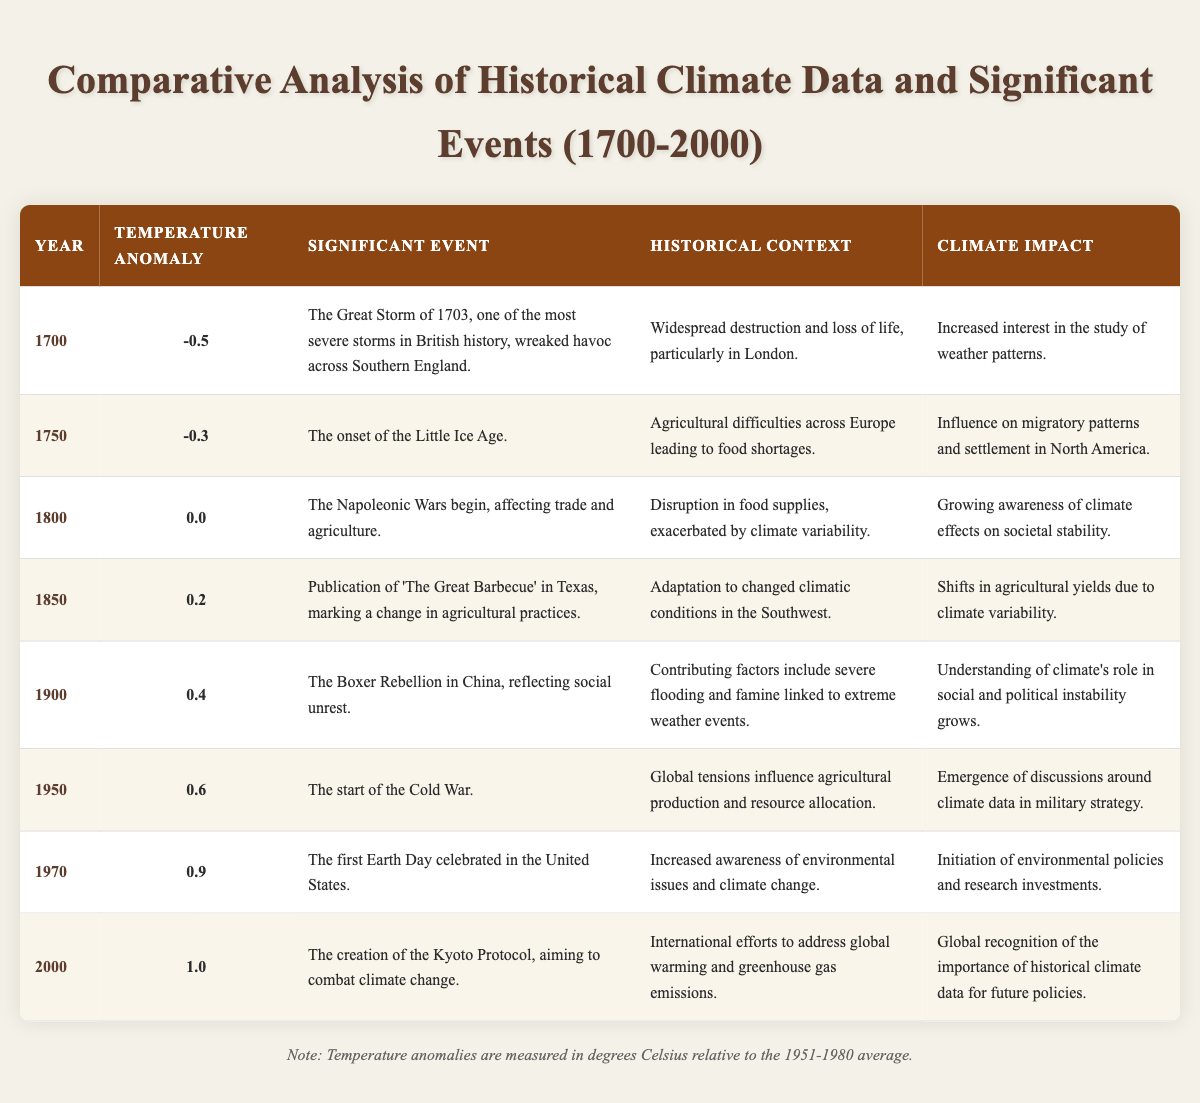What was the temperature anomaly in 1900? The table shows that the temperature anomaly for the year 1900 is 0.4 degrees Celsius.
Answer: 0.4 What significant event occurred in 1950? According to the table, the significant event in 1950 was the start of the Cold War.
Answer: Start of the Cold War Which year had the highest temperature anomaly? Analyzing the temperature anomalies listed, the highest value is 1.0 in the year 2000.
Answer: 2000 Was there a significant event linked to severe weather in 1800? The table indicates that the Napoleonic Wars, which began in 1800, were affected by disruptions in food supplies due to climate variability. Therefore, yes, this connects to severe weather.
Answer: Yes What was the temperature anomaly in the year of the Great Storm of 1703? The table notes that the year 1700, leading to the Great Storm of 1703, had a temperature anomaly of -0.5 degrees Celsius.
Answer: -0.5 What is the climate impact associated with the creation of the Kyoto Protocol in 2000? The impact listed for the year 2000 states the global recognition of the importance of historical climate data for future policies.
Answer: Global recognition of historical climate data importance Calculate the average temperature anomaly from 1700 to 2000. To find the average, add all temperature anomalies: (-0.5) + (-0.3) + 0.0 + 0.2 + 0.4 + 0.6 + 0.9 + 1.0 = 2.3. There are 8 data points, so 2.3 / 8 = 0.2875, approximately 0.29 degrees Celsius.
Answer: 0.29 In which year did the first Earth Day occur and what was the temperature anomaly that year? The table shows that the first Earth Day was celebrated in 1970 with a temperature anomaly of 0.9 degrees Celsius.
Answer: 1970, 0.9 Was there a historical context of famine linked to extreme weather during the Boxer Rebellion? The table confirms that the Boxer Rebellion in 1900 had contributing factors including severe flooding and famine linked to extreme weather events, making it true.
Answer: Yes From 1700 to 2000, how many significant events were influenced by climate-related issues? By reviewing the significant events, we find that events from 1700, 1750, 1800, 1900, and 1970 list climate-related influences, totaling 5 events.
Answer: 5 